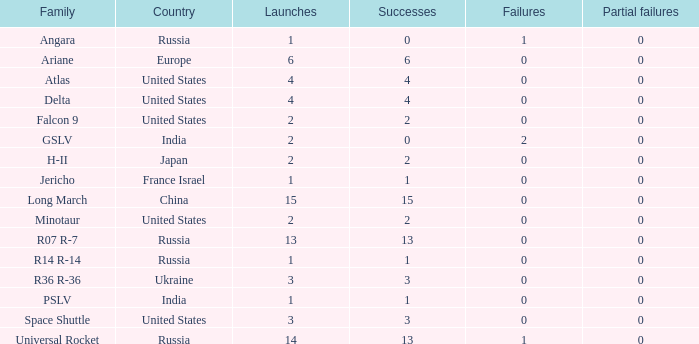What is the number of failure for the country of Russia, and a Family of r14 r-14, and a Partial failures smaller than 0? 0.0. 